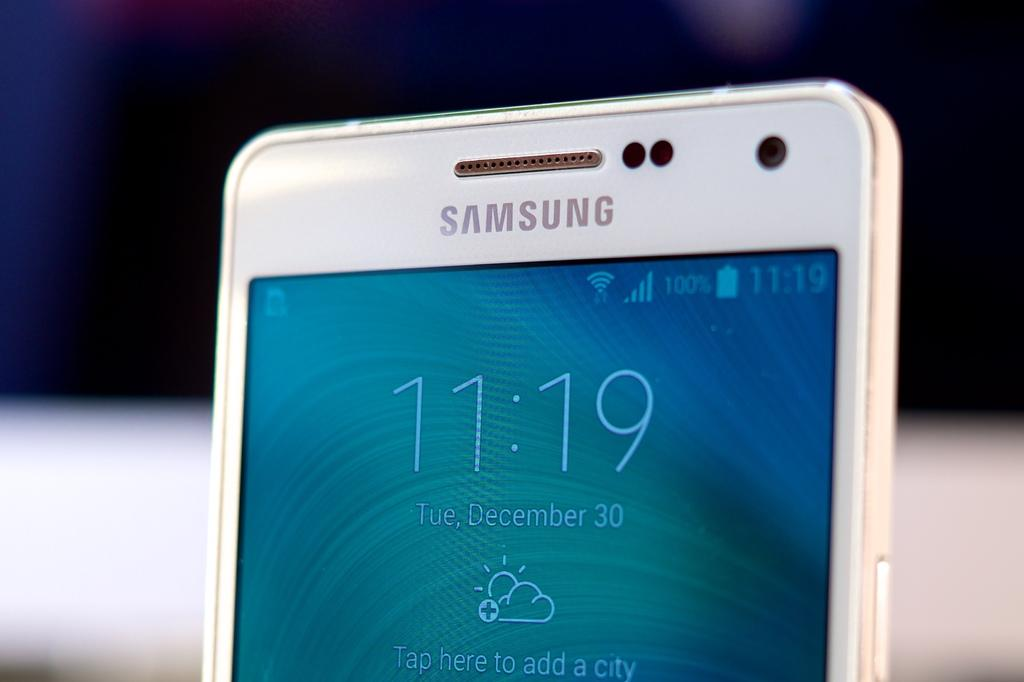<image>
Relay a brief, clear account of the picture shown. top part of samsung phone at 11:19 on December 30 